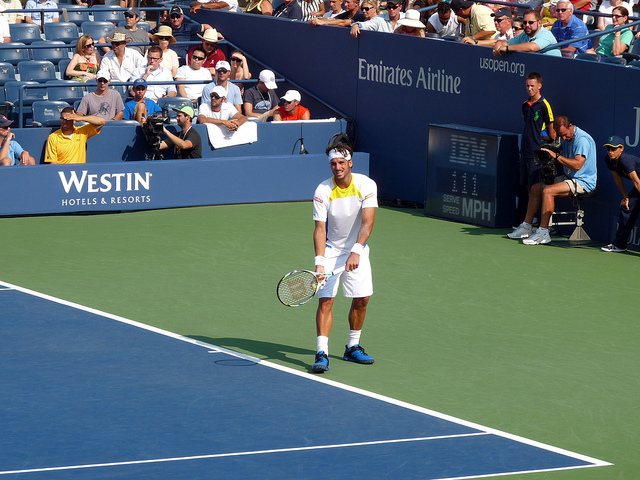<image>What car company is named on one of the bleachers? It is unclear which car company is named on one of the bleachers. It may be Emirates Airline, Westin, or Usocarcom. What car company is named on one of the bleachers? I am not sure what car company is named on one of the bleachers. It can be seen 'emirates airline', 'westin' or 'usocarcom'. 